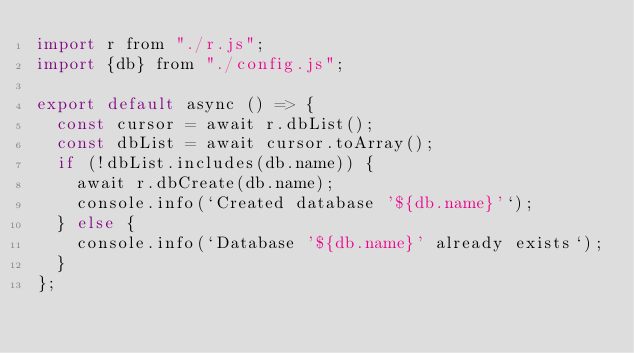Convert code to text. <code><loc_0><loc_0><loc_500><loc_500><_JavaScript_>import r from "./r.js";
import {db} from "./config.js";

export default async () => {
  const cursor = await r.dbList();
  const dbList = await cursor.toArray();
  if (!dbList.includes(db.name)) {
    await r.dbCreate(db.name);
    console.info(`Created database '${db.name}'`);
  } else {
    console.info(`Database '${db.name}' already exists`);
  }
};
</code> 